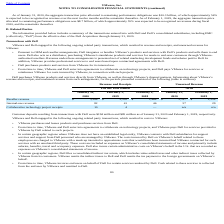According to Vmware's financial document, What were the customer deposits resulting from transactions with Dell in 2020? According to the financial document, $194 million. The relevant text states: "eposits resulting from transactions with Dell were $194 million and $85 million as of January 31, 2020 and February 1, 2019, respectively...." Also, What was the unearned reseller revenue as of 2019? According to the financial document, 2,554 (in millions). The relevant text states: "eseller revenue $ 3,288 $ 2,355 $ 1,464 $ 3,787 $ 2,554..." Also, What was the Collaborative technology project receipts revenue in 2019?  According to the financial document, 4 (in millions). The relevant text states: "ations was $10.3 billion, of which approximately 54%..." Also, can you calculate: What was the change in reseller revenue between 2018 and 2019? Based on the calculation: 2,355-1,464, the result is 891 (in millions). This is based on the information: "Reseller revenue $ 3,288 $ 2,355 $ 1,464 $ 3,787 $ 2,554 Reseller revenue $ 3,288 $ 2,355 $ 1,464 $ 3,787 $ 2,554..." The key data points involved are: 1,464, 2,355. Also, How many years did unearned Internal-use revenue exceed $30 million? Based on the analysis, there are 1 instances. The counting process: 2020. Also, can you calculate: What was the percentage change in the Collaborative technology project receipts revenue between 2019 and 2020? To answer this question, I need to perform calculations using the financial data. The calculation is: (10-4)/4, which equals 150 (percentage). This is based on the information: "Collaborative technology project receipts 10 4 — n/a n/a Collaborative technology project receipts 10 4 — n/a n/a..." The key data points involved are: 10, 4. 